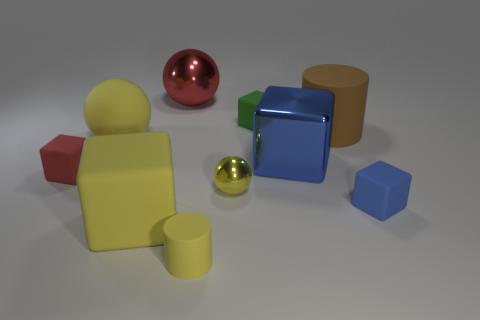How many spheres are there and what are their sizes in relation to each other? The image contains two spheres. One is a large red sphere with a reflective surface, and the other is a smaller golden sphere. The red sphere is considerably larger than the gold one, emphasizing the diversity in sizes among the spherical objects presented. 